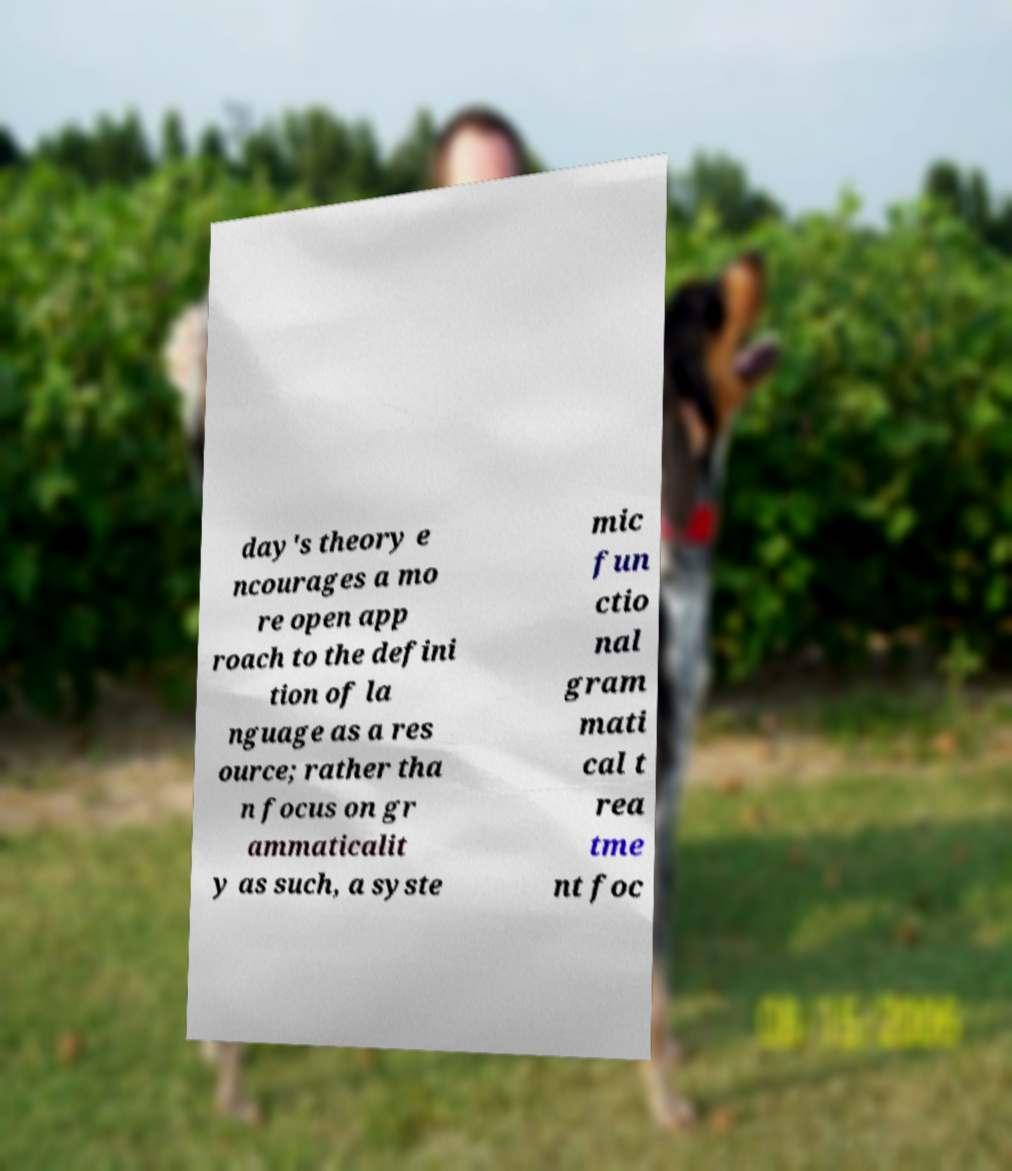Please identify and transcribe the text found in this image. day's theory e ncourages a mo re open app roach to the defini tion of la nguage as a res ource; rather tha n focus on gr ammaticalit y as such, a syste mic fun ctio nal gram mati cal t rea tme nt foc 